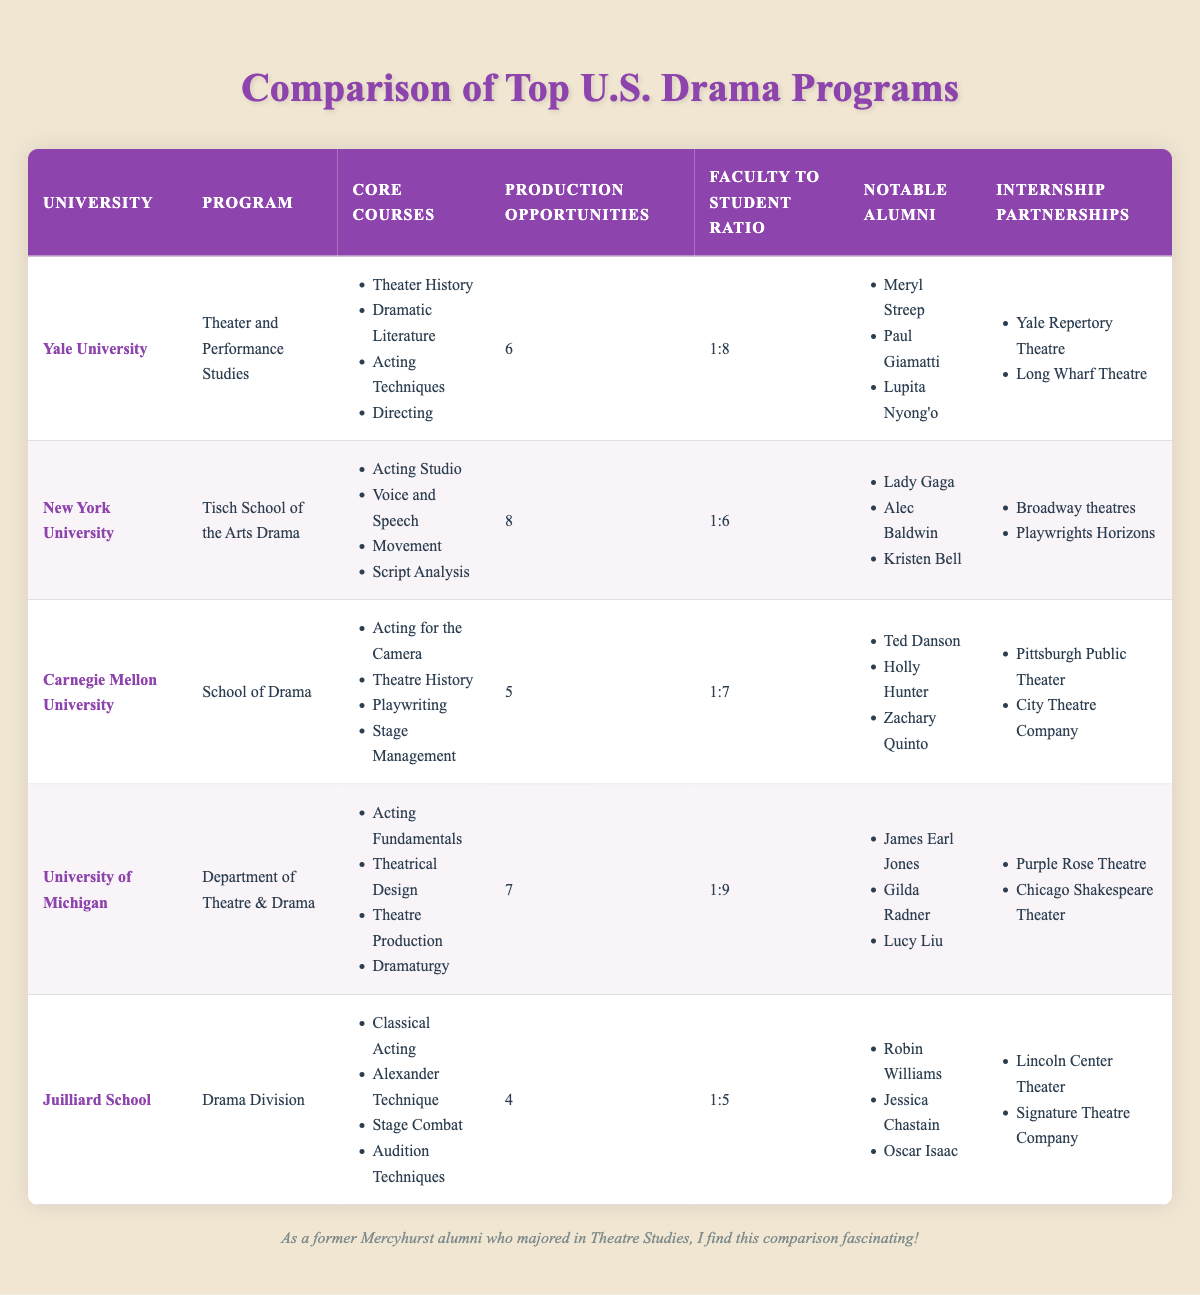What university has the highest number of production opportunities? Referring to the 'Production Opportunities' column, New York University has 8 production opportunities, which is the highest among all universities listed.
Answer: New York University Which university has the lowest faculty to student ratio? The 'Faculty to Student Ratio' for Juilliard School is 1:5, which is lower than the other universities listed, indicating more faculty support per student.
Answer: Juilliard School How many notable alumni does Carnegie Mellon University have listed? Carnegie Mellon University has three notable alumni listed: Ted Danson, Holly Hunter, and Zachary Quinto.
Answer: 3 What is the average number of production opportunities among these universities? To find the average, sum the production opportunities: 6 + 8 + 5 + 7 + 4 = 30. There are 5 universities, so the average is 30/5 = 6.
Answer: 6 Is there a university where the core courses include "Stage Combat"? The core courses listed for Juilliard School include "Stage Combat", confirming that they have this course in their curriculum.
Answer: Yes Which university offers "Dramaturgy" as a core course? The University of Michigan offers "Dramaturgy" as one of its core courses, as indicated in the table.
Answer: University of Michigan Which university has the most notable alumni in the table? Counting the notable alumni from each university, Yale has three notable alumni, NYU has three, Carnegie Mellon has three, Michigan has three, and Juilliard also has three. All universities have the same number of three notable alumni each.
Answer: All have three What is the difference in production opportunities between New York University and Juilliard School? New York University has 8 production opportunities and Juilliard School has 4. The difference is 8 - 4 = 4.
Answer: 4 Does the University of Michigan have any notable alumni who are playwrights? The notable alumni of the University of Michigan listed are James Earl Jones, Gilda Radner, and Lucy Liu. None of these are specifically noted as playwrights.
Answer: No 